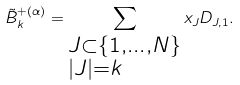<formula> <loc_0><loc_0><loc_500><loc_500>\tilde { B } _ { k } ^ { + ( \alpha ) } = \sum _ { \begin{subarray} { c } J \subset \{ 1 , \dots , N \} \\ | J | = k \end{subarray} } x _ { J } D _ { J , 1 } .</formula> 